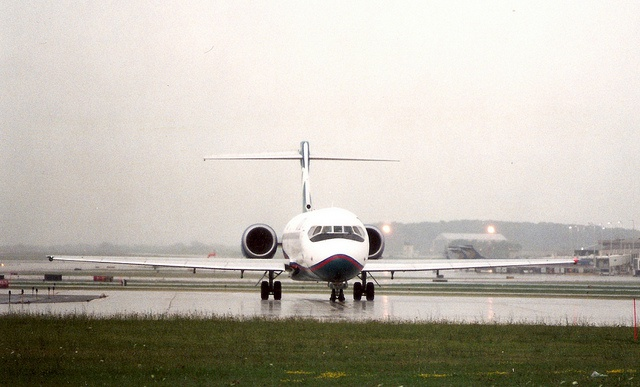Describe the objects in this image and their specific colors. I can see a airplane in lightgray, white, black, darkgray, and gray tones in this image. 